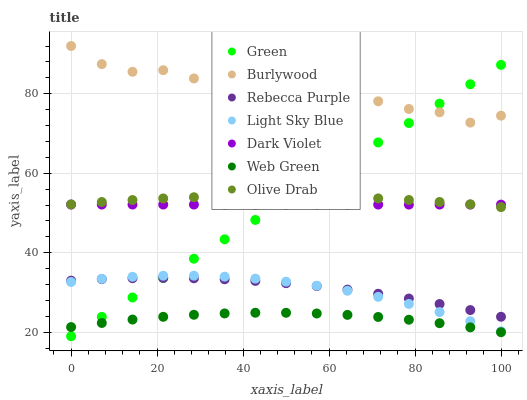Does Web Green have the minimum area under the curve?
Answer yes or no. Yes. Does Burlywood have the maximum area under the curve?
Answer yes or no. Yes. Does Dark Violet have the minimum area under the curve?
Answer yes or no. No. Does Dark Violet have the maximum area under the curve?
Answer yes or no. No. Is Green the smoothest?
Answer yes or no. Yes. Is Burlywood the roughest?
Answer yes or no. Yes. Is Dark Violet the smoothest?
Answer yes or no. No. Is Dark Violet the roughest?
Answer yes or no. No. Does Green have the lowest value?
Answer yes or no. Yes. Does Dark Violet have the lowest value?
Answer yes or no. No. Does Burlywood have the highest value?
Answer yes or no. Yes. Does Dark Violet have the highest value?
Answer yes or no. No. Is Rebecca Purple less than Burlywood?
Answer yes or no. Yes. Is Burlywood greater than Dark Violet?
Answer yes or no. Yes. Does Light Sky Blue intersect Rebecca Purple?
Answer yes or no. Yes. Is Light Sky Blue less than Rebecca Purple?
Answer yes or no. No. Is Light Sky Blue greater than Rebecca Purple?
Answer yes or no. No. Does Rebecca Purple intersect Burlywood?
Answer yes or no. No. 